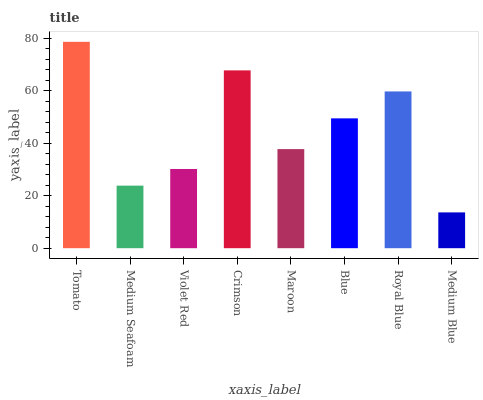Is Medium Blue the minimum?
Answer yes or no. Yes. Is Tomato the maximum?
Answer yes or no. Yes. Is Medium Seafoam the minimum?
Answer yes or no. No. Is Medium Seafoam the maximum?
Answer yes or no. No. Is Tomato greater than Medium Seafoam?
Answer yes or no. Yes. Is Medium Seafoam less than Tomato?
Answer yes or no. Yes. Is Medium Seafoam greater than Tomato?
Answer yes or no. No. Is Tomato less than Medium Seafoam?
Answer yes or no. No. Is Blue the high median?
Answer yes or no. Yes. Is Maroon the low median?
Answer yes or no. Yes. Is Medium Blue the high median?
Answer yes or no. No. Is Violet Red the low median?
Answer yes or no. No. 